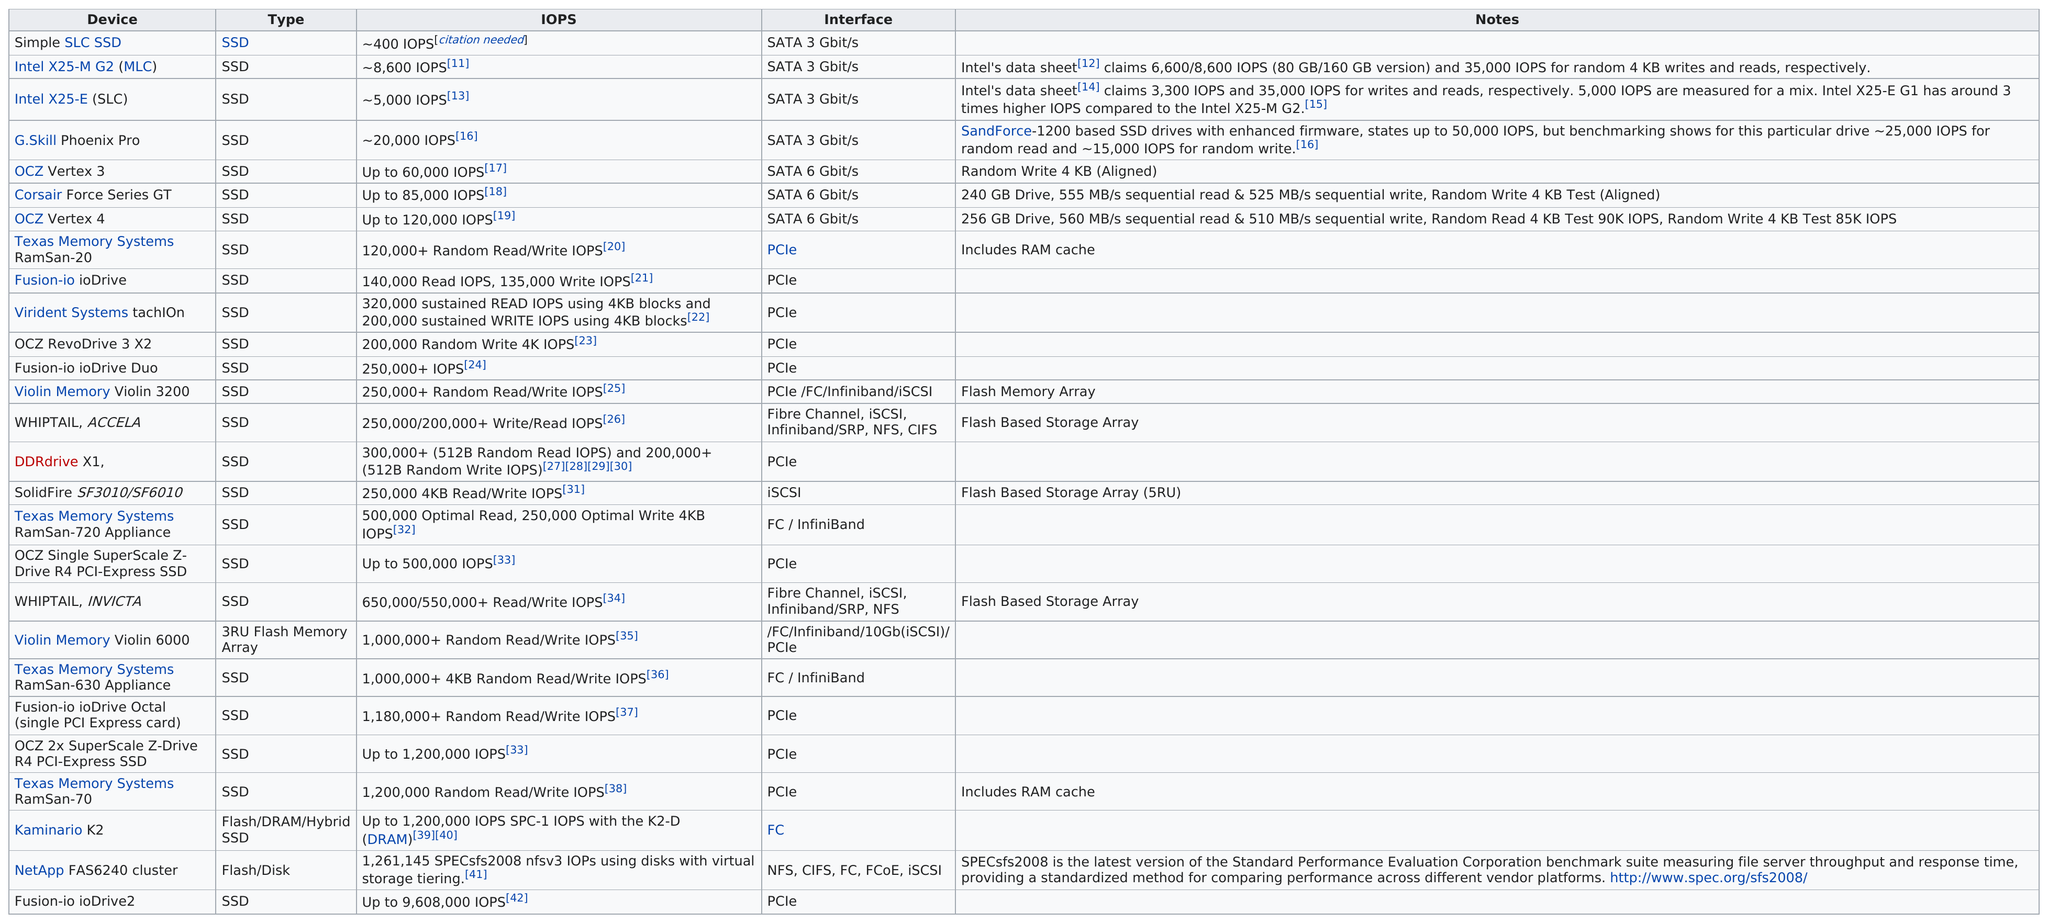Specify some key components in this picture. The Violin Memory Violin 3200 is the only device that features a "flash memory array. If Violet owned a Texas Memory Systems RamSan 630, it would have a fast interface such as Fibre Channel or InfiniBand. The NetApp FAS6240 cluster hard drive has a maximum of 1,200,000 IOPS, but it is not an SSD. The OCZ Vertex 3 can handle up to 60,000 IOPS, making it a powerful and capable storage solution for high-performance computing needs. The SATA 6 Gbit/s interface appears first. 